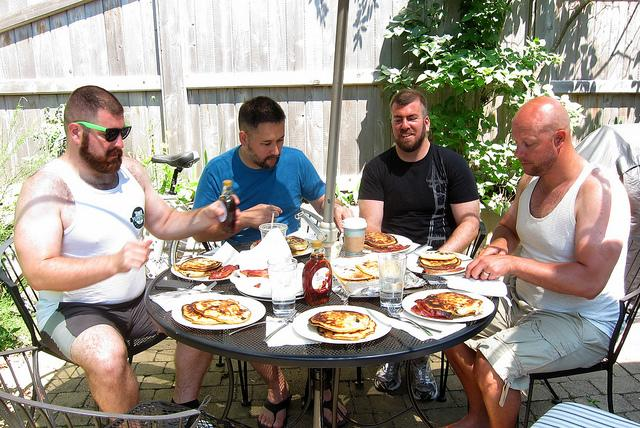What food on the table has the highest level of fat?

Choices:
A) bacon
B) syrup
C) pancake
D) egg bacon 